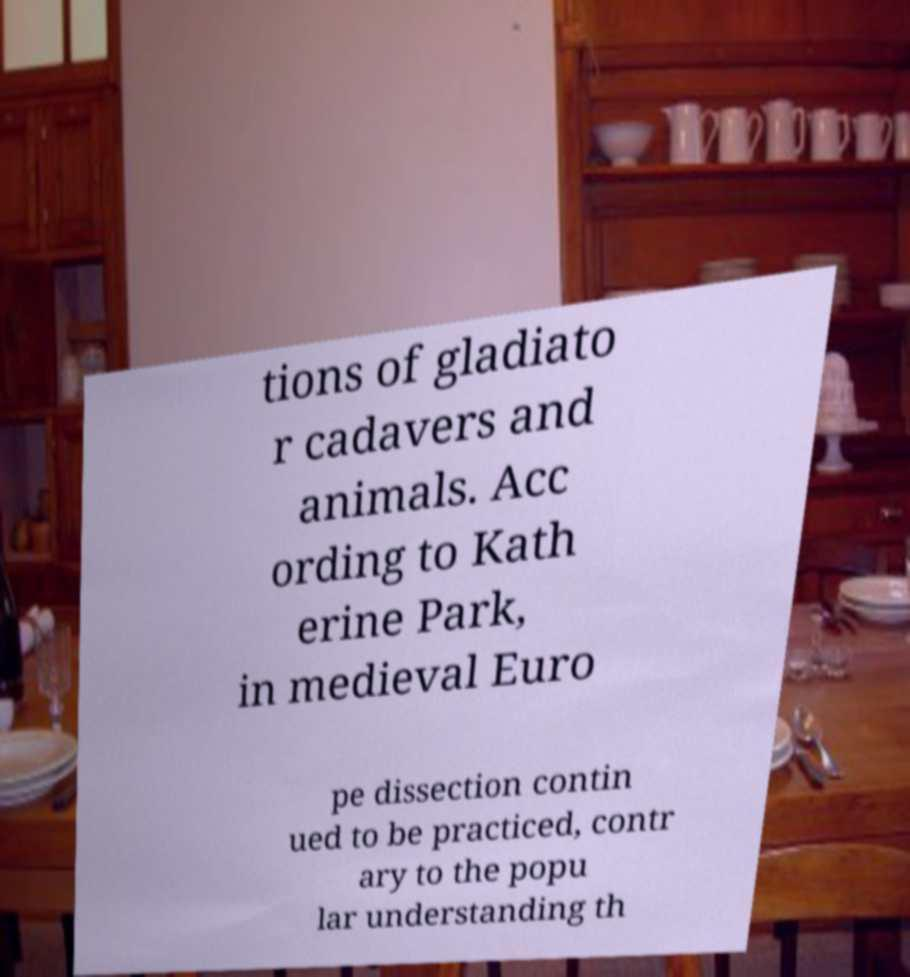Could you assist in decoding the text presented in this image and type it out clearly? tions of gladiato r cadavers and animals. Acc ording to Kath erine Park, in medieval Euro pe dissection contin ued to be practiced, contr ary to the popu lar understanding th 